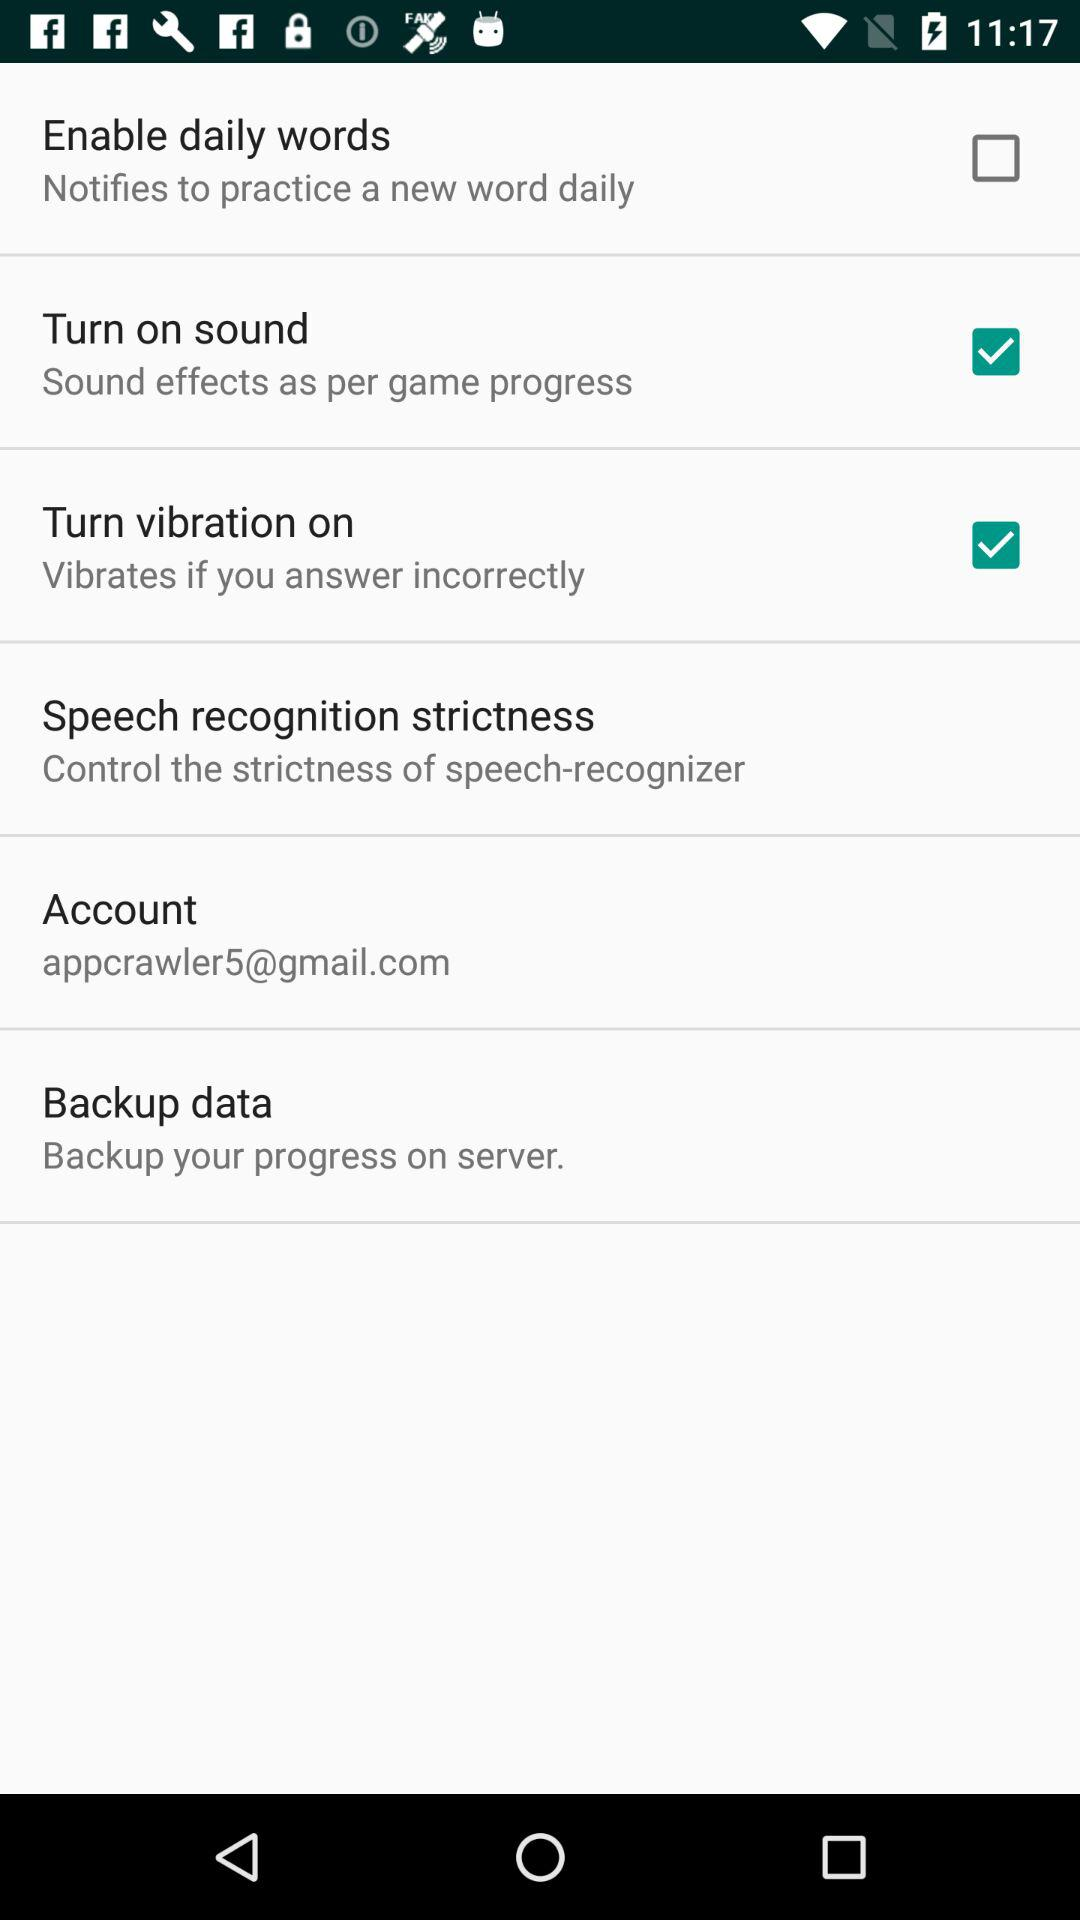How many check boxes are there in the settings menu?
Answer the question using a single word or phrase. 3 